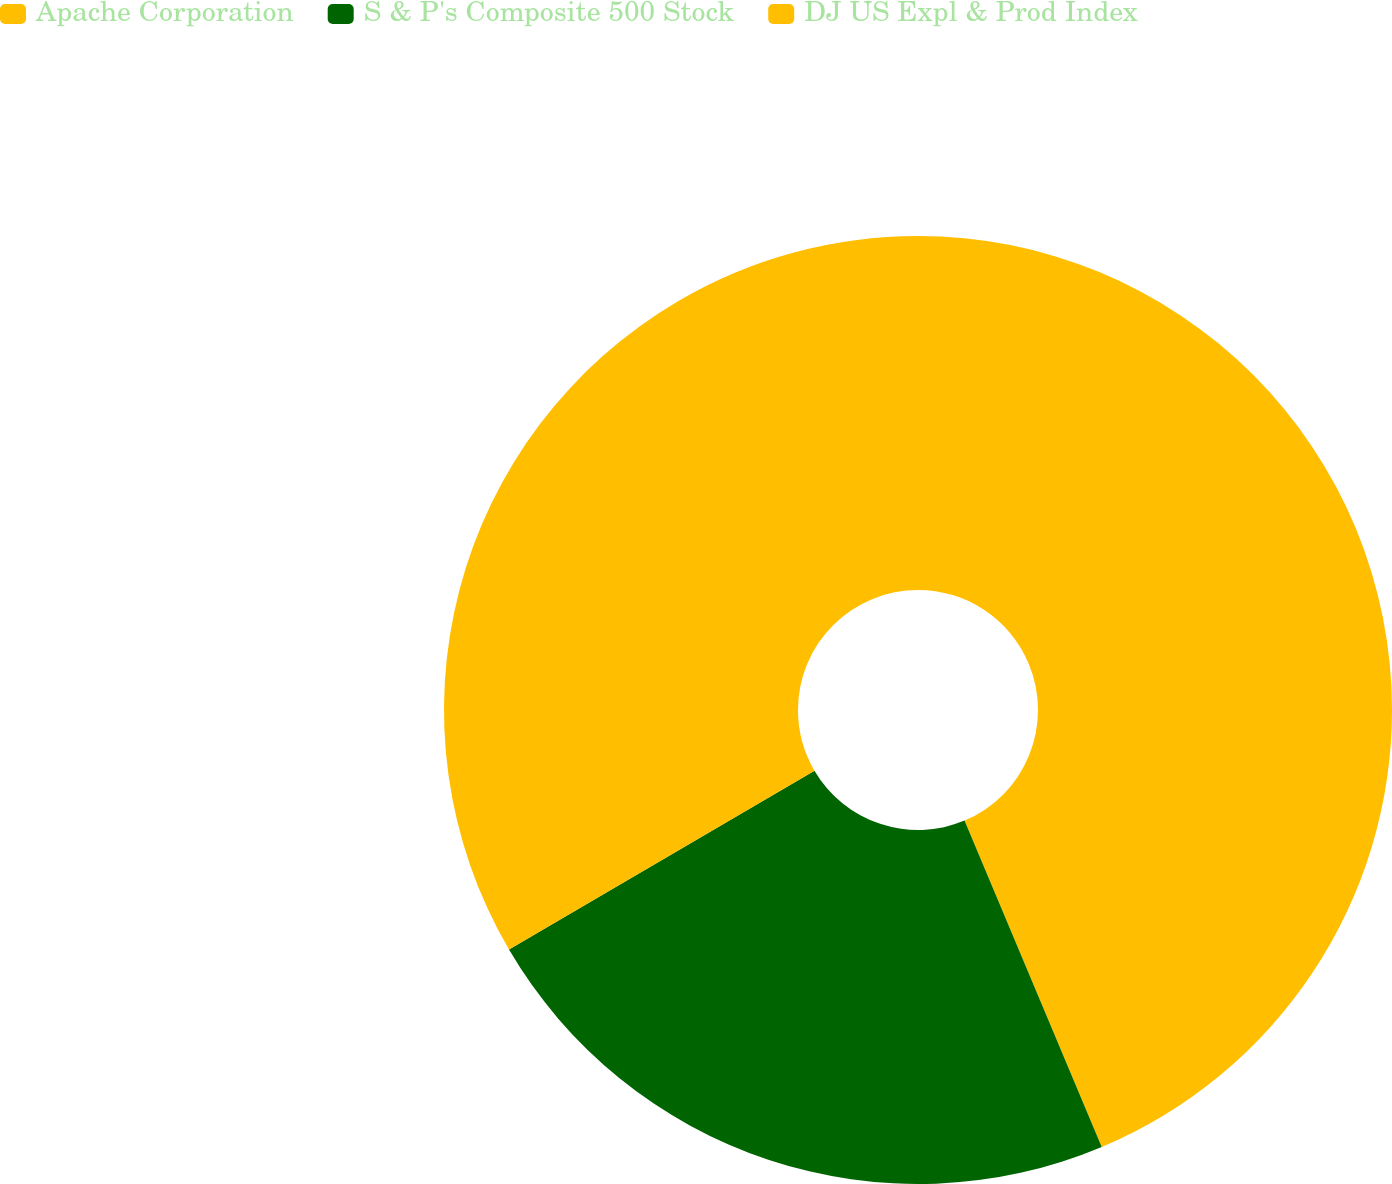Convert chart. <chart><loc_0><loc_0><loc_500><loc_500><pie_chart><fcel>Apache Corporation<fcel>S & P's Composite 500 Stock<fcel>DJ US Expl & Prod Index<nl><fcel>43.66%<fcel>22.9%<fcel>33.43%<nl></chart> 